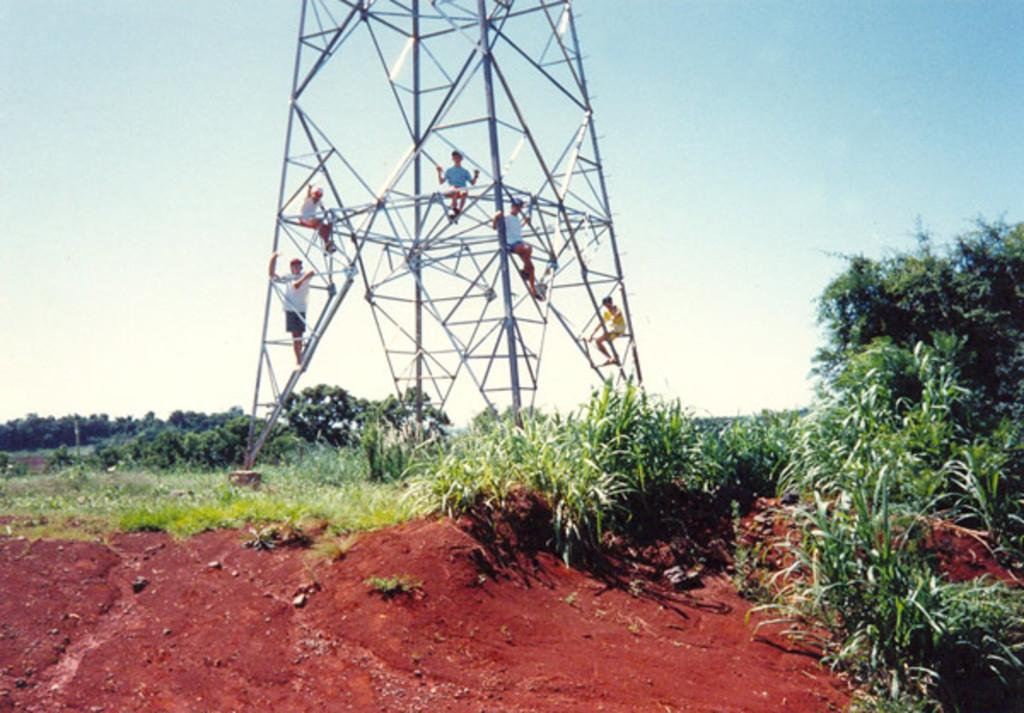What is the main structure in the image? There is a tower in the image. Are there any people present in the image? Yes, there are people on the tower. What type of vegetation can be seen in the image? There are trees and plants in the image. What is the ground covered with in the image? The ground is covered with grass in the image. What can be seen in the background of the image? The sky is visible in the background of the image. What type of sign can be seen on the tower in the image? There is no sign visible on the tower in the image. Can you tell me how many cows are grazing on the grass in the image? There are no cows present in the image; it only features a tower, people, trees, plants, grass, and the sky. 